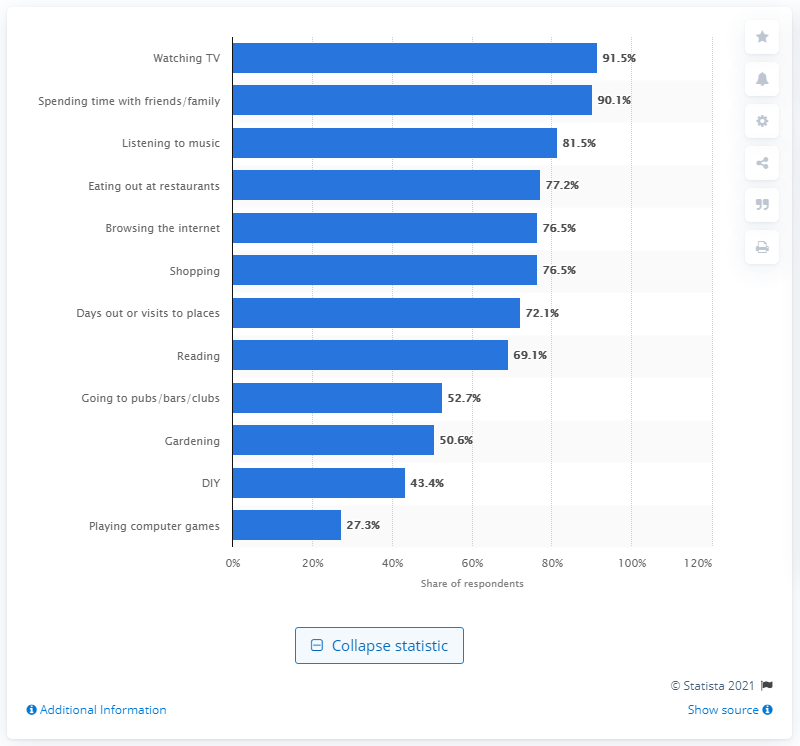Identify some key points in this picture. Watching TV is the most popular activity that people engage in during their free time in England. 